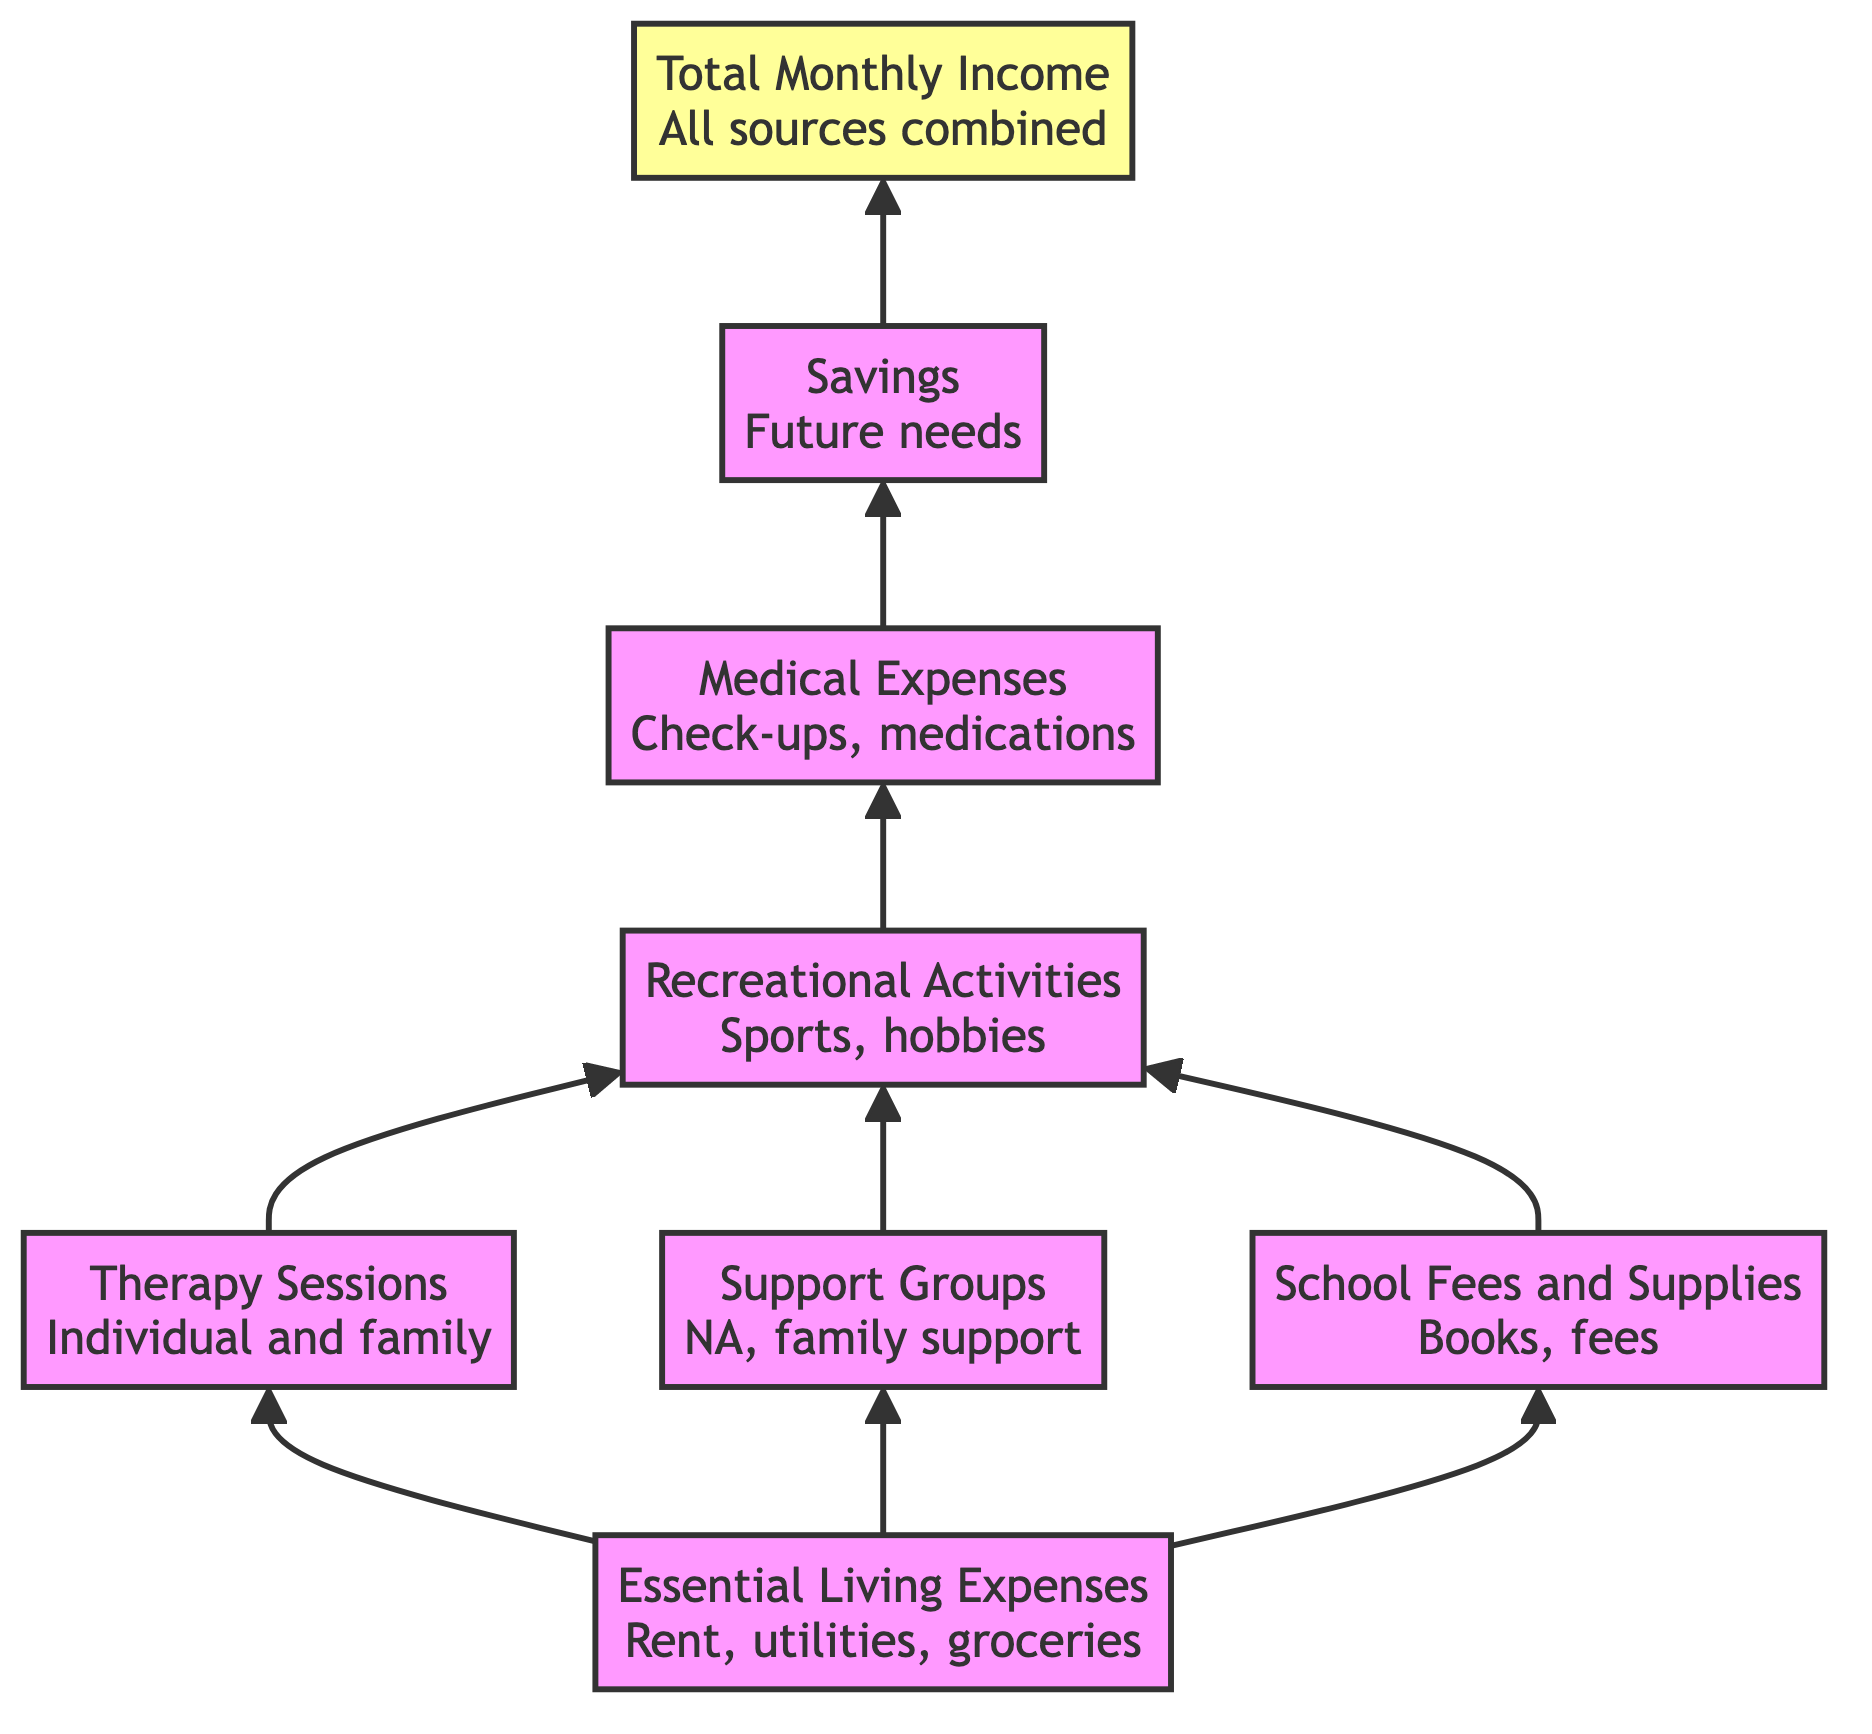What do we allocate for therapy sessions? The diagram lists "Therapy Sessions" as one of the expenses that comes directly from "Essential Living Expenses." This indicates a clear allocation for therapy services.
Answer: Therapy Sessions How many categories contribute to "Recreational Activities"? The diagram shows that both "Therapy Sessions" and "Support Groups" contribute to "Recreational Activities," meaning there are two categories providing funds for this expense.
Answer: Two What is the top node in this flow chart? The flow chart's structure clearly indicates that the top node, which is the final output, is "Total Monthly Income." It represents the culminating value reflecting the total funds available.
Answer: Total Monthly Income Which two nodes feed directly into "Recreational Activities"? According to the flow, both "Therapy Sessions" and "Support Groups" have direct arrows leading to "Recreational Activities." This shows that these two expenses combine to fund recreational activities.
Answer: Therapy Sessions and Support Groups How many total nodes are represented in the diagram? To find the total nodes, we count each distinct category or expense listed. There are eight nodes in total represented in the diagram.
Answer: Eight What is allocated for medical and health expenses? "Medical and Health Expenses" comes after "Recreational Activities" in the flow. This indicates that funds are allocated specifically for medical needs, which are necessary for the family's well-being.
Answer: Medical and Health Expenses Which node is the immediate predecessor of "Savings"? The diagram indicates that "Medical and Health Expenses" flows directly into "Savings," meaning that's the immediate predecessor in the flow structure.
Answer: Medical and Health Expenses What is the first node in the hierarchical structure? The structure initiates with "Essential Living Expenses," showing it as the starting point from which all other categories and expenses derive.
Answer: Essential Living Expenses 